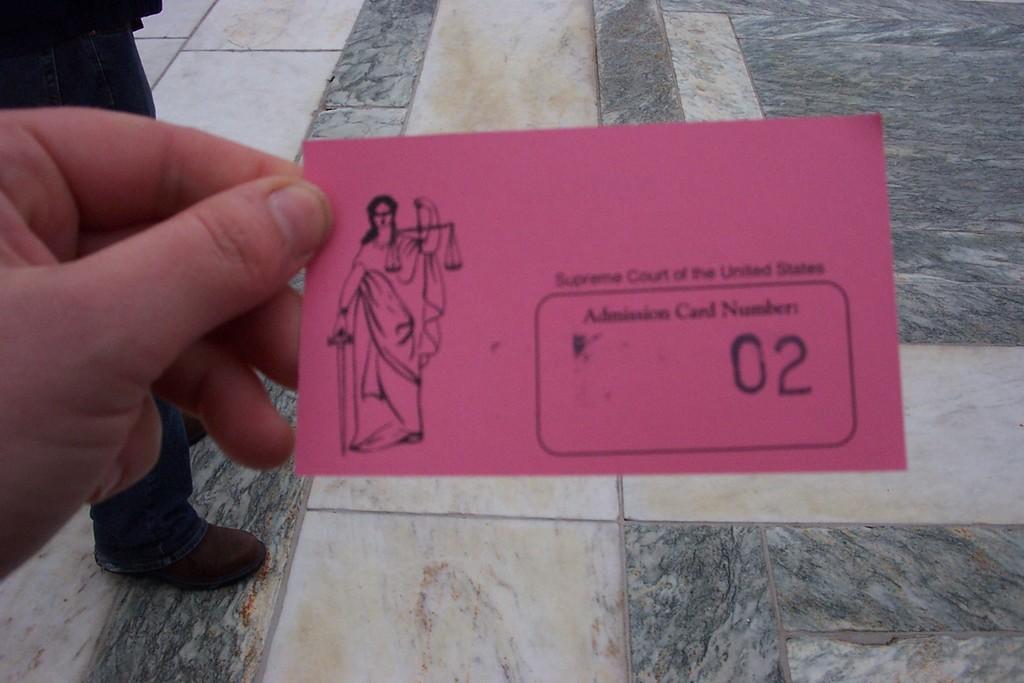Could you give a brief overview of what you see in this image? In this image we can see there is a person standing on the floor. And there is another person hand holding a paper. 